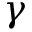Convert formula to latex. <formula><loc_0><loc_0><loc_500><loc_500>\gamma</formula> 